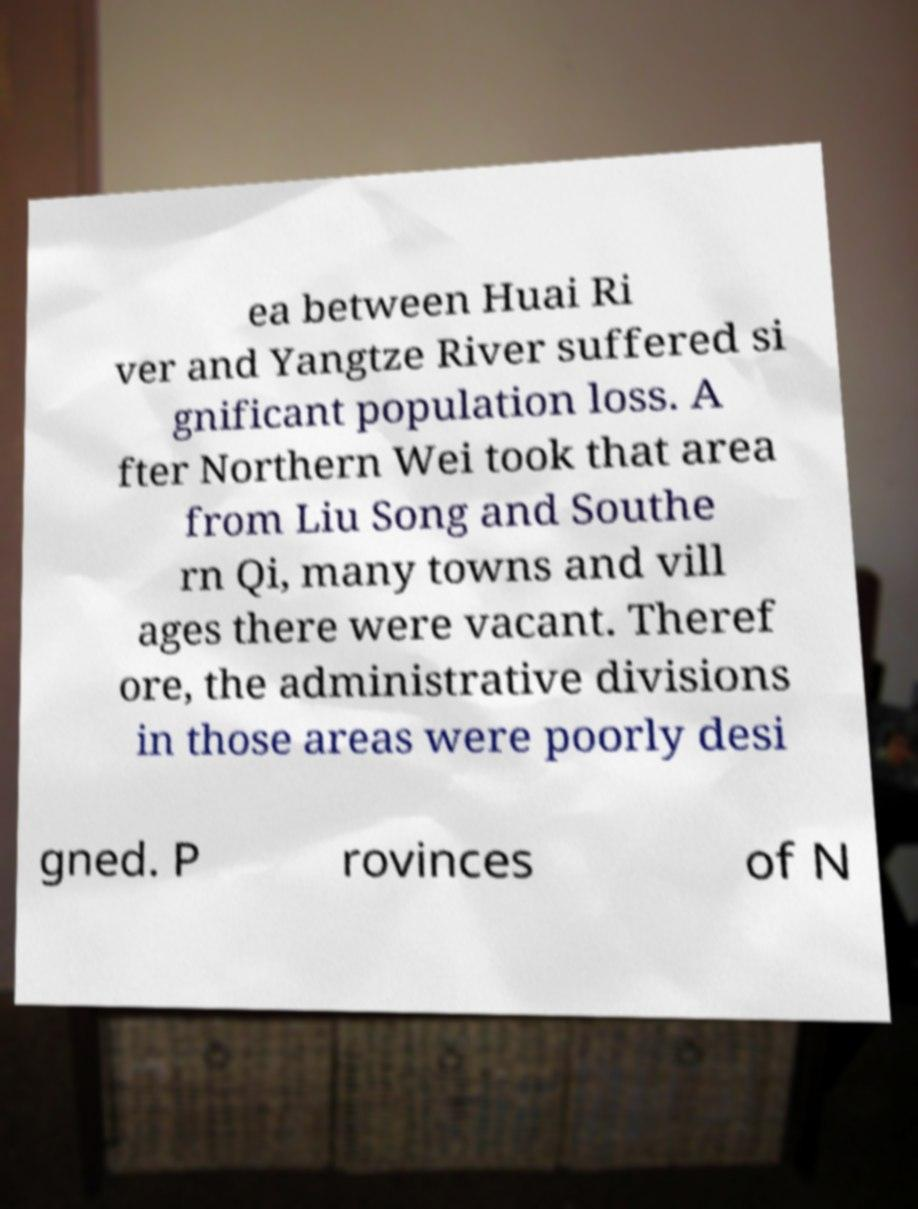I need the written content from this picture converted into text. Can you do that? ea between Huai Ri ver and Yangtze River suffered si gnificant population loss. A fter Northern Wei took that area from Liu Song and Southe rn Qi, many towns and vill ages there were vacant. Theref ore, the administrative divisions in those areas were poorly desi gned. P rovinces of N 